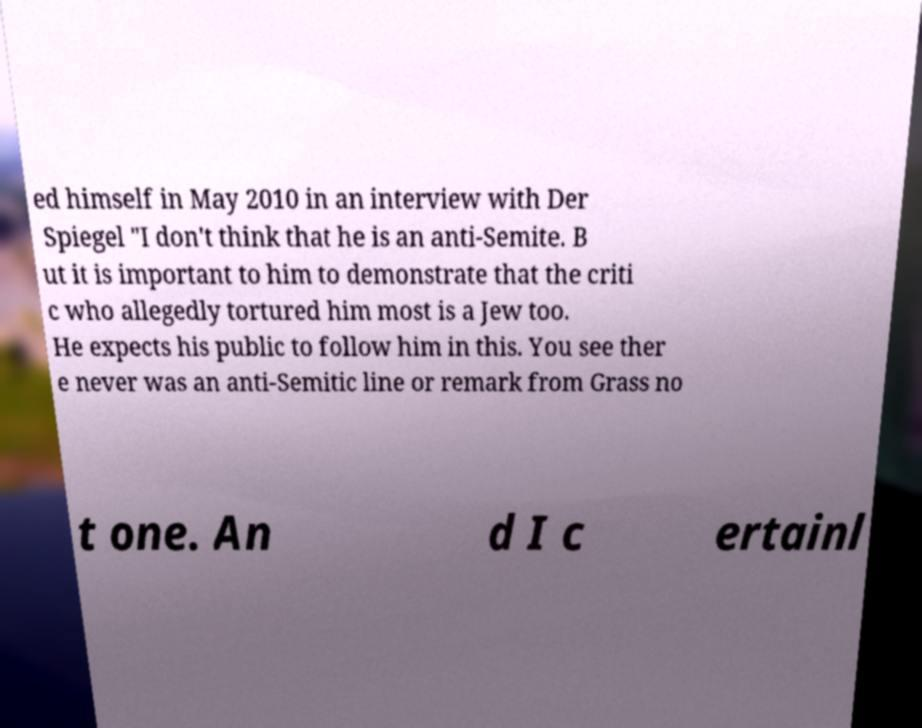Could you extract and type out the text from this image? ed himself in May 2010 in an interview with Der Spiegel "I don't think that he is an anti-Semite. B ut it is important to him to demonstrate that the criti c who allegedly tortured him most is a Jew too. He expects his public to follow him in this. You see ther e never was an anti-Semitic line or remark from Grass no t one. An d I c ertainl 